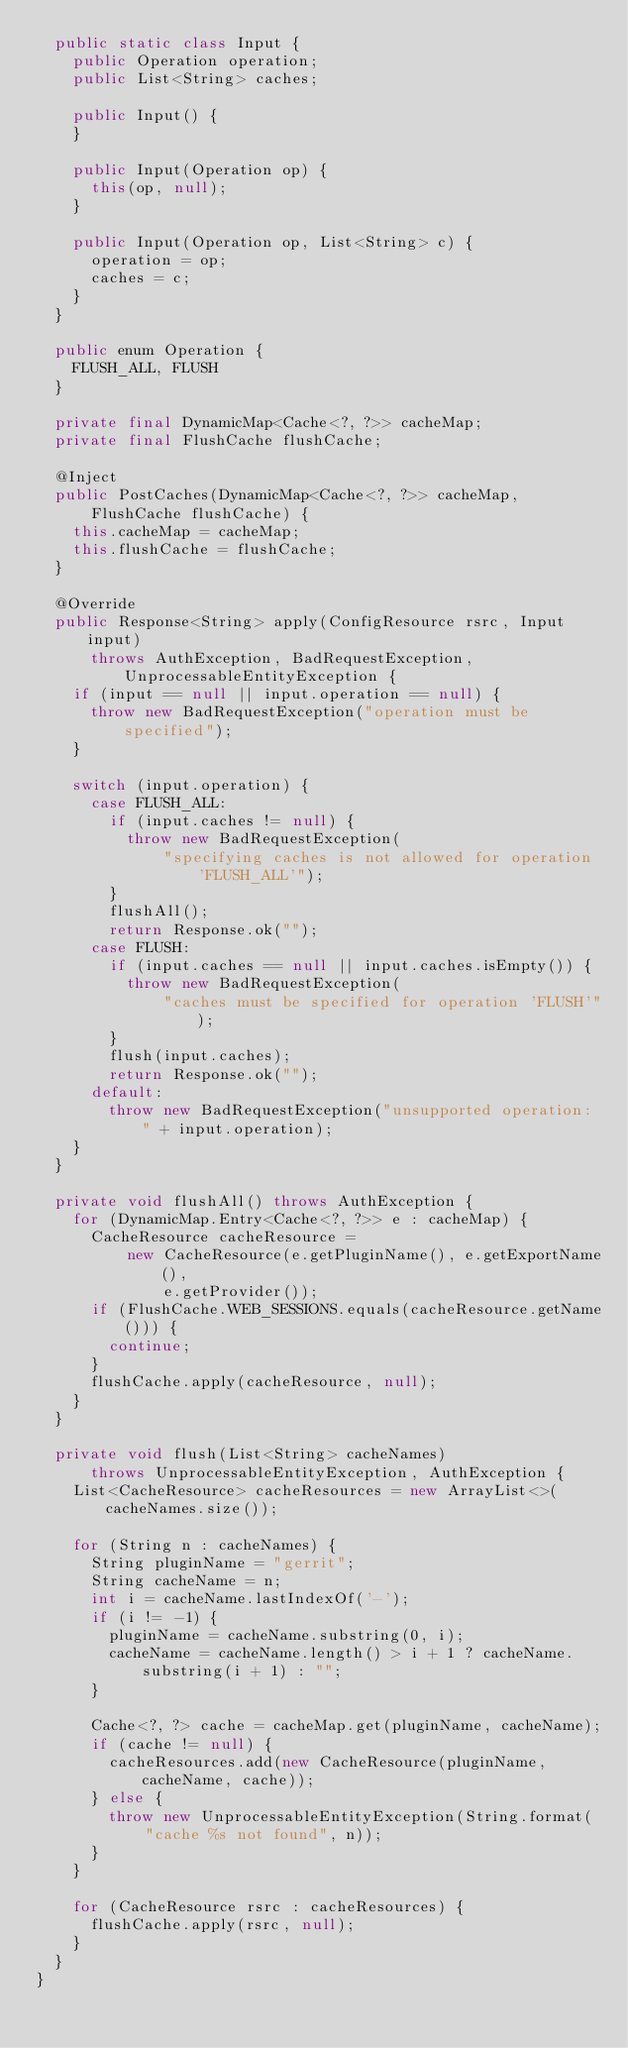Convert code to text. <code><loc_0><loc_0><loc_500><loc_500><_Java_>  public static class Input {
    public Operation operation;
    public List<String> caches;

    public Input() {
    }

    public Input(Operation op) {
      this(op, null);
    }

    public Input(Operation op, List<String> c) {
      operation = op;
      caches = c;
    }
  }

  public enum Operation {
    FLUSH_ALL, FLUSH
  }

  private final DynamicMap<Cache<?, ?>> cacheMap;
  private final FlushCache flushCache;

  @Inject
  public PostCaches(DynamicMap<Cache<?, ?>> cacheMap,
      FlushCache flushCache) {
    this.cacheMap = cacheMap;
    this.flushCache = flushCache;
  }

  @Override
  public Response<String> apply(ConfigResource rsrc, Input input)
      throws AuthException, BadRequestException, UnprocessableEntityException {
    if (input == null || input.operation == null) {
      throw new BadRequestException("operation must be specified");
    }

    switch (input.operation) {
      case FLUSH_ALL:
        if (input.caches != null) {
          throw new BadRequestException(
              "specifying caches is not allowed for operation 'FLUSH_ALL'");
        }
        flushAll();
        return Response.ok("");
      case FLUSH:
        if (input.caches == null || input.caches.isEmpty()) {
          throw new BadRequestException(
              "caches must be specified for operation 'FLUSH'");
        }
        flush(input.caches);
        return Response.ok("");
      default:
        throw new BadRequestException("unsupported operation: " + input.operation);
    }
  }

  private void flushAll() throws AuthException {
    for (DynamicMap.Entry<Cache<?, ?>> e : cacheMap) {
      CacheResource cacheResource =
          new CacheResource(e.getPluginName(), e.getExportName(),
              e.getProvider());
      if (FlushCache.WEB_SESSIONS.equals(cacheResource.getName())) {
        continue;
      }
      flushCache.apply(cacheResource, null);
    }
  }

  private void flush(List<String> cacheNames)
      throws UnprocessableEntityException, AuthException {
    List<CacheResource> cacheResources = new ArrayList<>(cacheNames.size());

    for (String n : cacheNames) {
      String pluginName = "gerrit";
      String cacheName = n;
      int i = cacheName.lastIndexOf('-');
      if (i != -1) {
        pluginName = cacheName.substring(0, i);
        cacheName = cacheName.length() > i + 1 ? cacheName.substring(i + 1) : "";
      }

      Cache<?, ?> cache = cacheMap.get(pluginName, cacheName);
      if (cache != null) {
        cacheResources.add(new CacheResource(pluginName, cacheName, cache));
      } else {
        throw new UnprocessableEntityException(String.format(
            "cache %s not found", n));
      }
    }

    for (CacheResource rsrc : cacheResources) {
      flushCache.apply(rsrc, null);
    }
  }
}
</code> 